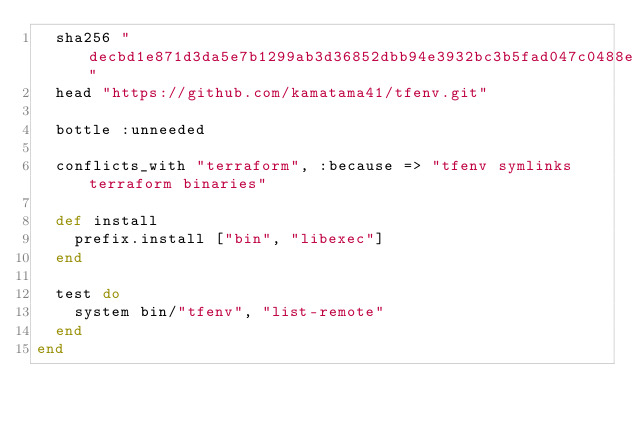<code> <loc_0><loc_0><loc_500><loc_500><_Ruby_>  sha256 "decbd1e871d3da5e7b1299ab3d36852dbb94e3932bc3b5fad047c0488e4eac1b"
  head "https://github.com/kamatama41/tfenv.git"

  bottle :unneeded

  conflicts_with "terraform", :because => "tfenv symlinks terraform binaries"

  def install
    prefix.install ["bin", "libexec"]
  end

  test do
    system bin/"tfenv", "list-remote"
  end
end
</code> 